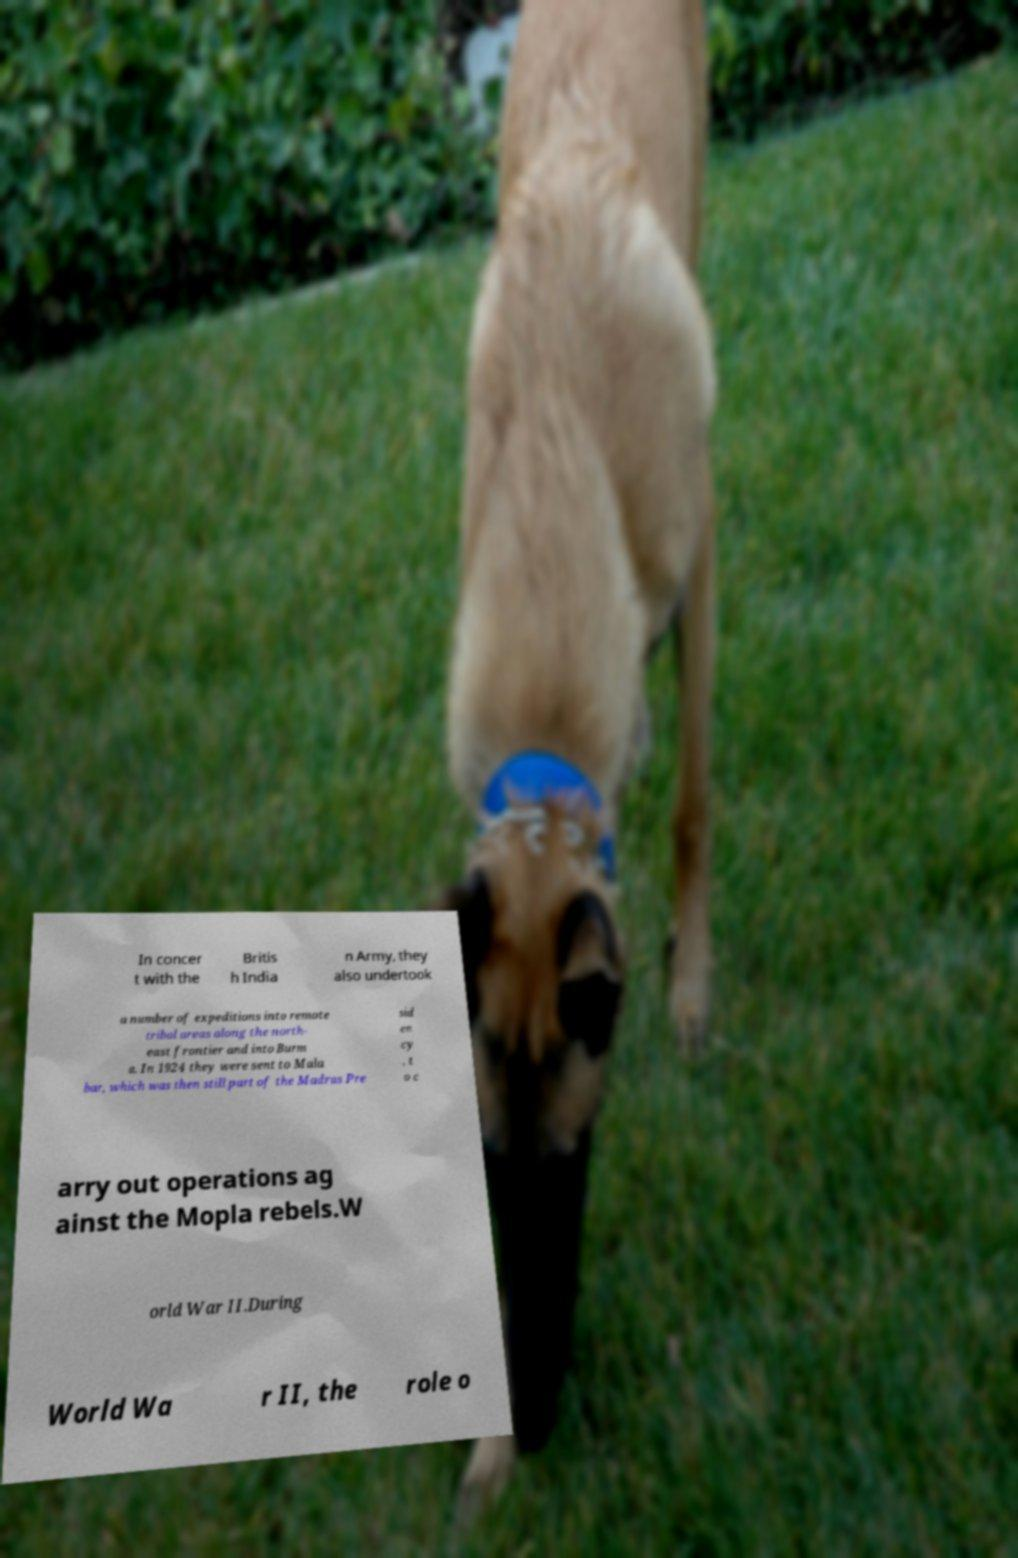Could you assist in decoding the text presented in this image and type it out clearly? In concer t with the Britis h India n Army, they also undertook a number of expeditions into remote tribal areas along the north- east frontier and into Burm a. In 1924 they were sent to Mala bar, which was then still part of the Madras Pre sid en cy , t o c arry out operations ag ainst the Mopla rebels.W orld War II.During World Wa r II, the role o 